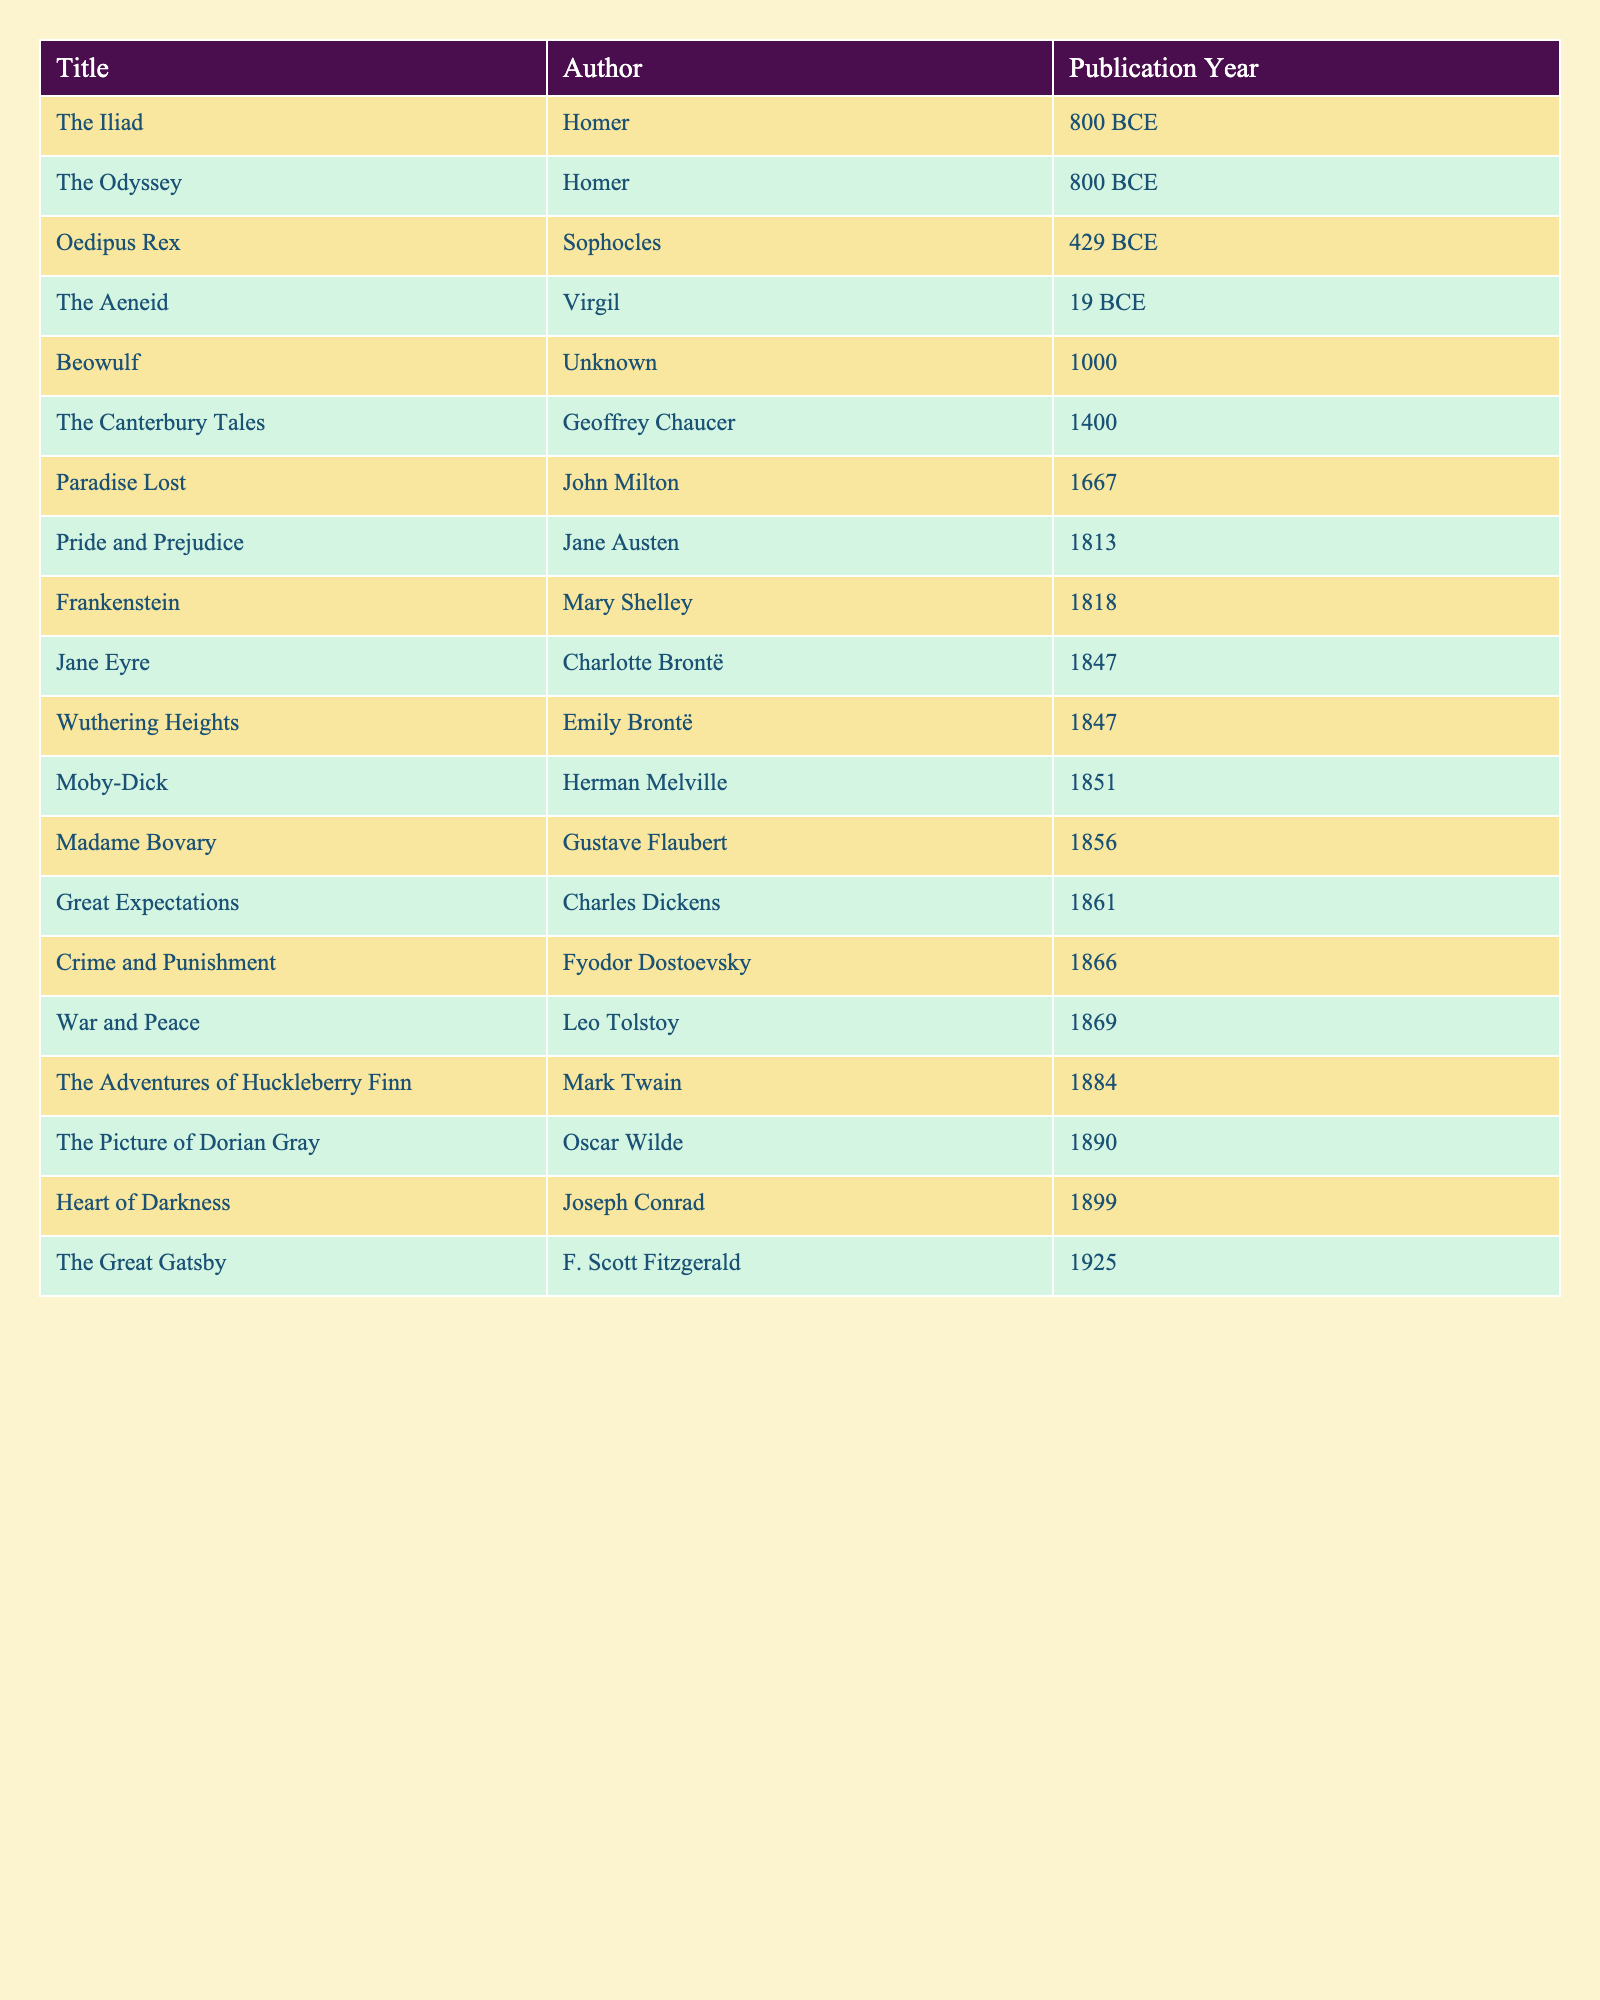What is the publication year of "Pride and Prejudice"? The table lists "Pride and Prejudice" as having a publication year of 1813.
Answer: 1813 Who authored "The Great Gatsby"? According to the table, "The Great Gatsby" was authored by F. Scott Fitzgerald.
Answer: F. Scott Fitzgerald What is the earliest publication year of the works listed? The earliest publication year in the table is 800 BCE, associated with "The Iliad" and "The Odyssey."
Answer: 800 BCE What is the latest publication year? The latest publication year listed is 1925 for "The Great Gatsby."
Answer: 1925 How many works were published in the 19th century (1801-1900)? The works published in the 19th century are "Pride and Prejudice," "Frankenstein," "Wuthering Heights," "Jane Eyre," "Moby-Dick," "Madame Bovary," "Great Expectations," "Crime and Punishment," "War and Peace," and "The Adventures of Huckleberry Finn," totaling 10 works.
Answer: 10 Was "Frankenstein" published before "Crime and Punishment"? "Frankenstein" was published in 1818 and "Crime and Punishment" in 1866; thus, "Frankenstein" was published before "Crime and Punishment."
Answer: Yes Which author wrote the most works among those listed? The table shows that the Brontë sisters authored two works each ("Wuthering Heights" and "Jane Eyre"), but other authors have only one work listed. Therefore, the Brontë sisters are among the most prolific in this table, but no single author wrote more than that.
Answer: No author wrote more than one work If we look at publications from the BCE era, how many works are listed? The table reveals two works from the BCE era: "The Iliad" and "The Odyssey."
Answer: 2 What is the average publication year of the works listed? To find the average, we calculate the total years. The works span from 800 BCE (considered as -800) to 1925, totaling 27 pieces of works. The sum of years is -800 + -800 + -429 + -19 + 1000 + 1400 + 1667 + 1813 + 1818 + 1847 + 1847 + 1851 + 1856 + 1861 + 1866 + 1869 + 1884 + 1890 + 1899 + 1925 = 3816. To find the average: 3816 / 27 = 141.3 (approx.) Thus, the average publication year is around 141 CE.
Answer: 141 CE Is "Beowulf" older than "The Canterbury Tales"? "Beowulf" was published around 1000, while "The Canterbury Tales" was published in 1400; therefore, "Beowulf" is older.
Answer: Yes Which work was published closest to the 20th century? The closest work to the 20th century in the table is "The Great Gatsby," published in 1925.
Answer: The Great Gatsby 